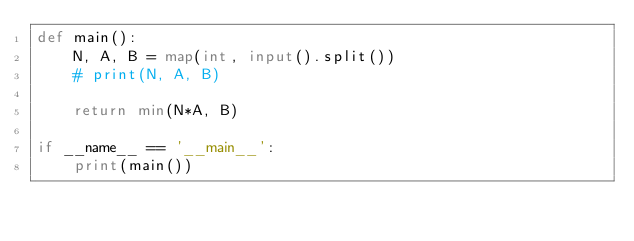<code> <loc_0><loc_0><loc_500><loc_500><_Python_>def main():
    N, A, B = map(int, input().split())
    # print(N, A, B)

    return min(N*A, B)

if __name__ == '__main__':
    print(main())</code> 